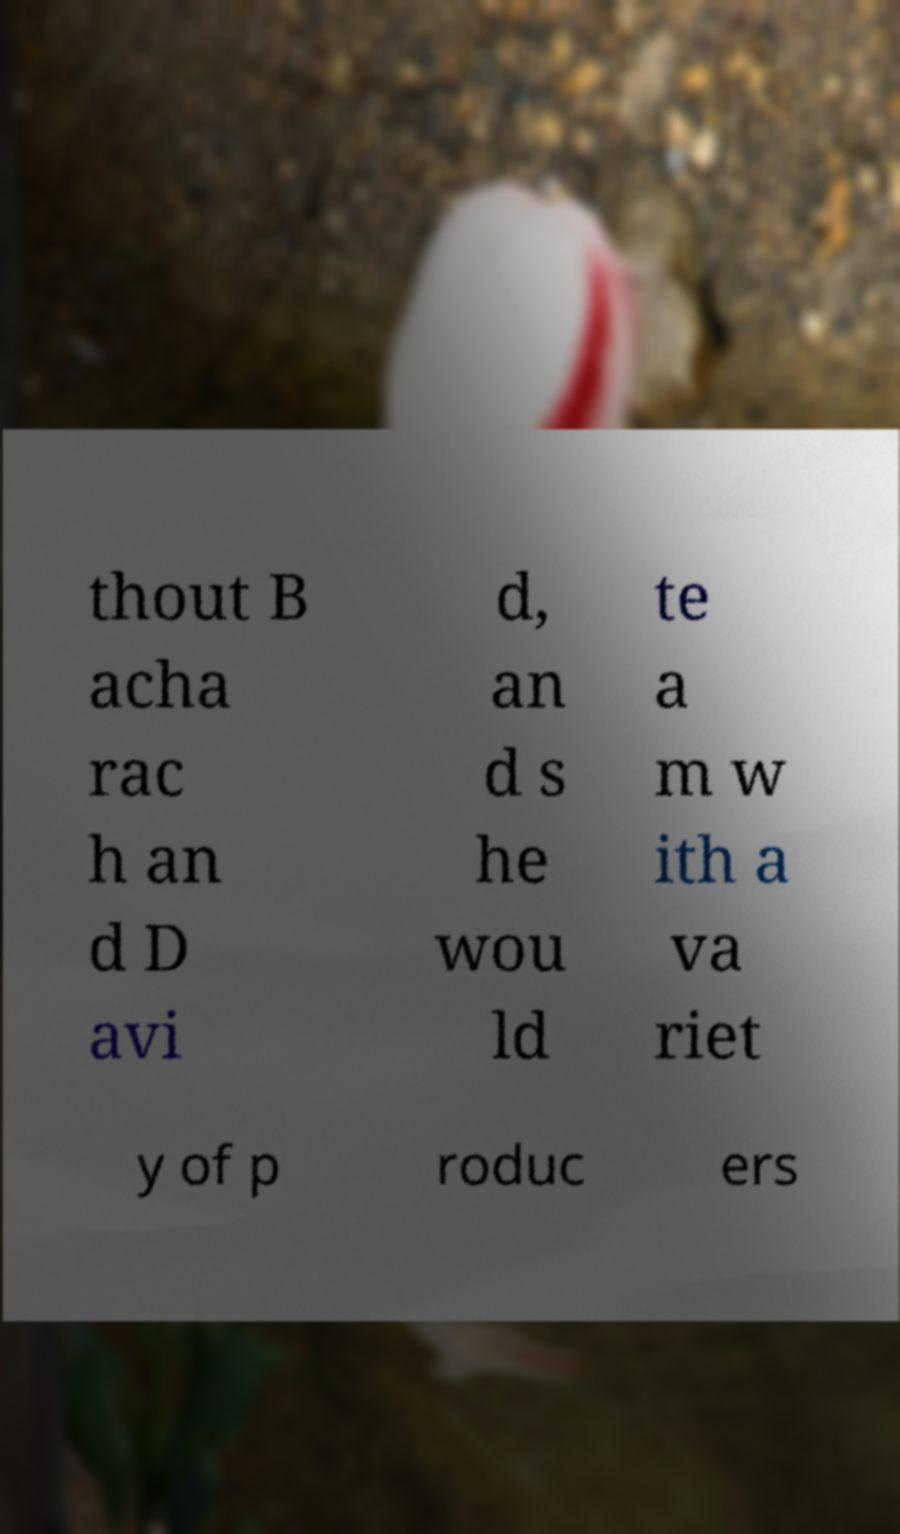There's text embedded in this image that I need extracted. Can you transcribe it verbatim? thout B acha rac h an d D avi d, an d s he wou ld te a m w ith a va riet y of p roduc ers 